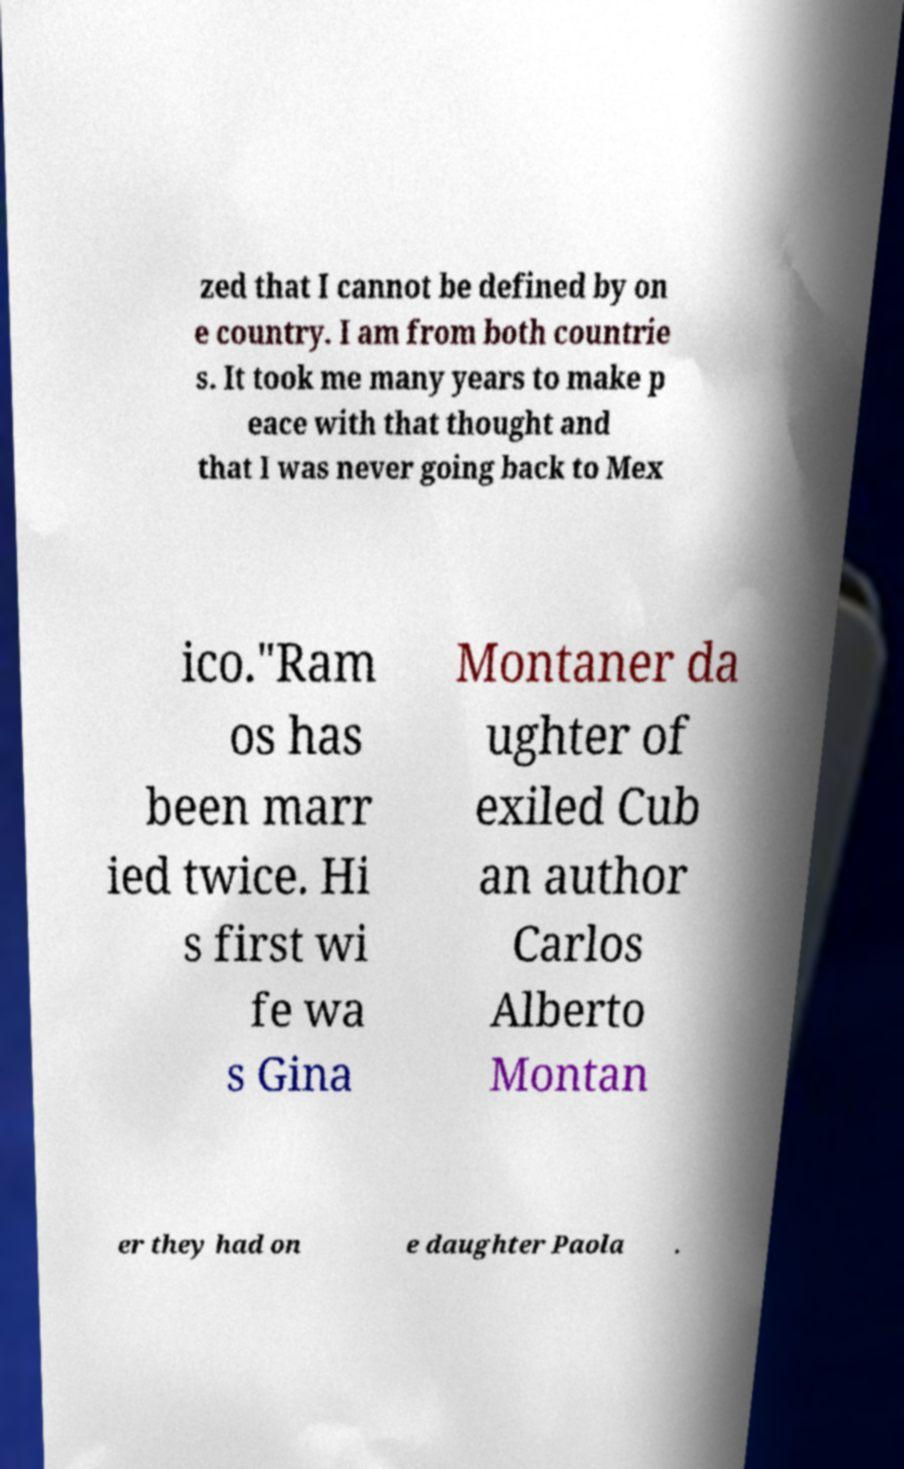Could you assist in decoding the text presented in this image and type it out clearly? zed that I cannot be defined by on e country. I am from both countrie s. It took me many years to make p eace with that thought and that I was never going back to Mex ico."Ram os has been marr ied twice. Hi s first wi fe wa s Gina Montaner da ughter of exiled Cub an author Carlos Alberto Montan er they had on e daughter Paola . 